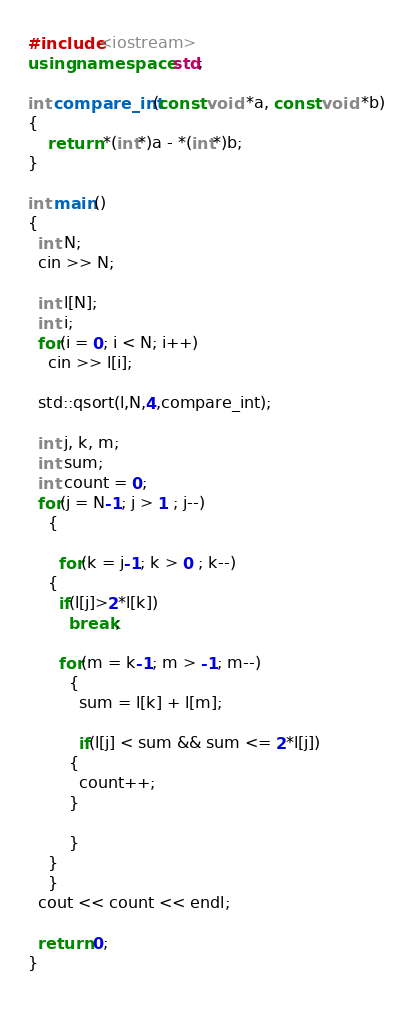Convert code to text. <code><loc_0><loc_0><loc_500><loc_500><_C++_>#include<iostream>
using namespace std;

int compare_int(const void *a, const void *b)
{
    return *(int*)a - *(int*)b;
}

int main()
{
  int N;
  cin >> N;

  int l[N];
  int i;
  for(i = 0; i < N; i++)
    cin >> l[i];
  
  std::qsort(l,N,4,compare_int);

  int j, k, m;
  int sum;
  int count = 0;
  for(j = N-1; j > 1 ; j--)
    {
      
      for(k = j-1; k > 0 ; k--)
	{
	  if(l[j]>2*l[k])
	    break;
	  
	  for(m = k-1; m > -1; m--)
	    {
	      sum = l[k] + l[m];

	      if(l[j] < sum && sum <= 2*l[j])
		{
		  count++;
		}

	    }
	}
    }
  cout << count << endl;

  return 0;
}
      
</code> 